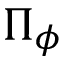<formula> <loc_0><loc_0><loc_500><loc_500>\Pi _ { \phi }</formula> 